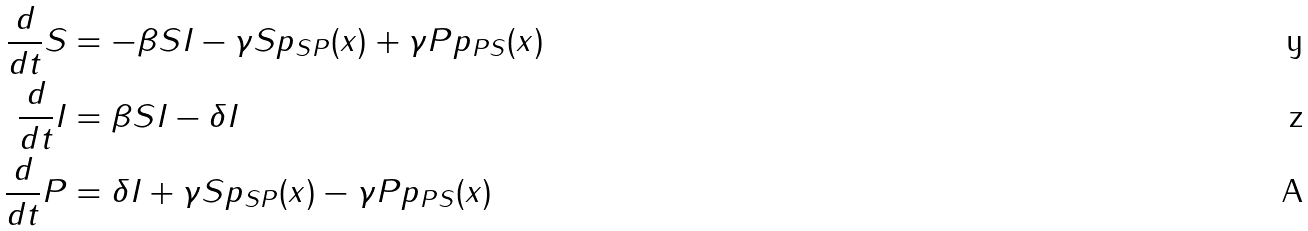<formula> <loc_0><loc_0><loc_500><loc_500>\frac { d } { d t } S & = - \beta S I - \gamma S p _ { S P } ( x ) + \gamma P p _ { P S } ( x ) \\ \frac { d } { d t } I & = \beta S I - \delta I \\ \frac { d } { d t } P & = \delta I + \gamma S p _ { S P } ( x ) - \gamma P p _ { P S } ( x )</formula> 